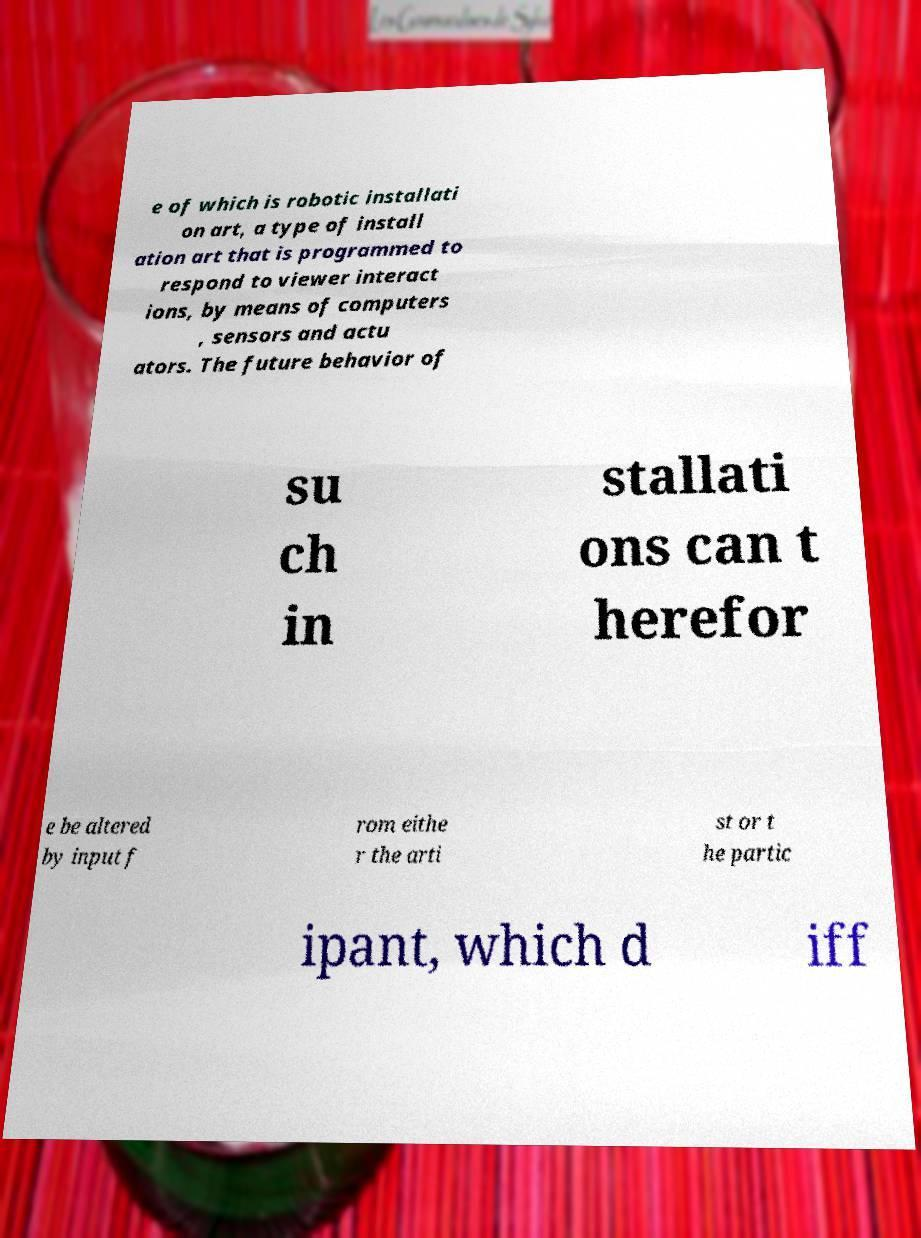Could you assist in decoding the text presented in this image and type it out clearly? e of which is robotic installati on art, a type of install ation art that is programmed to respond to viewer interact ions, by means of computers , sensors and actu ators. The future behavior of su ch in stallati ons can t herefor e be altered by input f rom eithe r the arti st or t he partic ipant, which d iff 